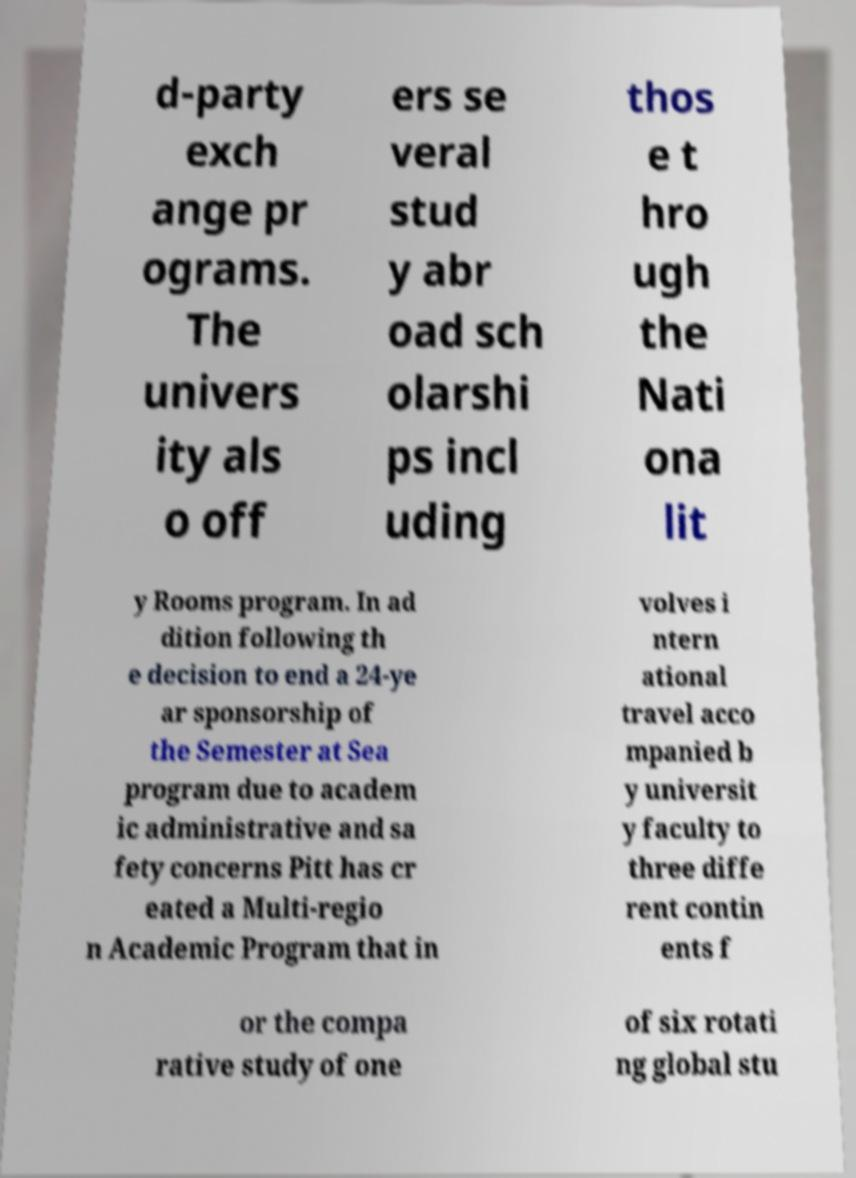Can you accurately transcribe the text from the provided image for me? d-party exch ange pr ograms. The univers ity als o off ers se veral stud y abr oad sch olarshi ps incl uding thos e t hro ugh the Nati ona lit y Rooms program. In ad dition following th e decision to end a 24-ye ar sponsorship of the Semester at Sea program due to academ ic administrative and sa fety concerns Pitt has cr eated a Multi-regio n Academic Program that in volves i ntern ational travel acco mpanied b y universit y faculty to three diffe rent contin ents f or the compa rative study of one of six rotati ng global stu 